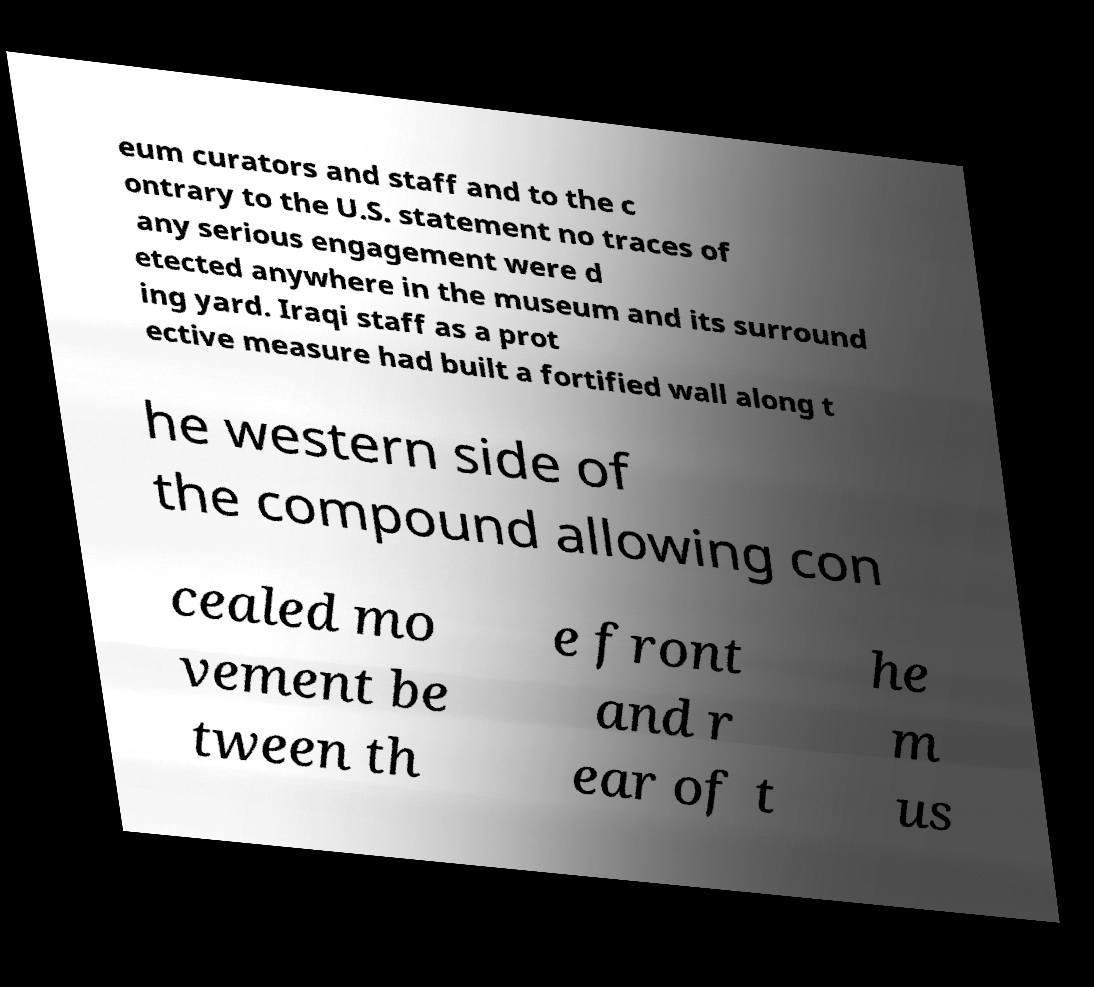What messages or text are displayed in this image? I need them in a readable, typed format. eum curators and staff and to the c ontrary to the U.S. statement no traces of any serious engagement were d etected anywhere in the museum and its surround ing yard. Iraqi staff as a prot ective measure had built a fortified wall along t he western side of the compound allowing con cealed mo vement be tween th e front and r ear of t he m us 